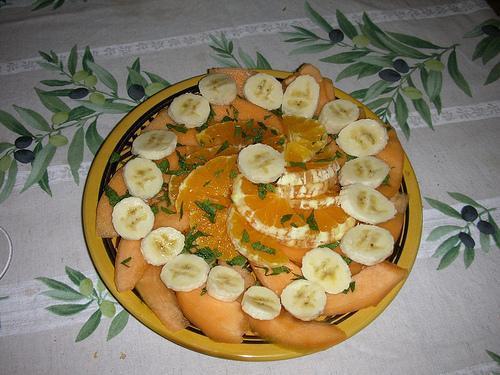How many oranges are there?
Give a very brief answer. 3. How many bananas can be seen?
Give a very brief answer. 5. How many people in white shoes?
Give a very brief answer. 0. 